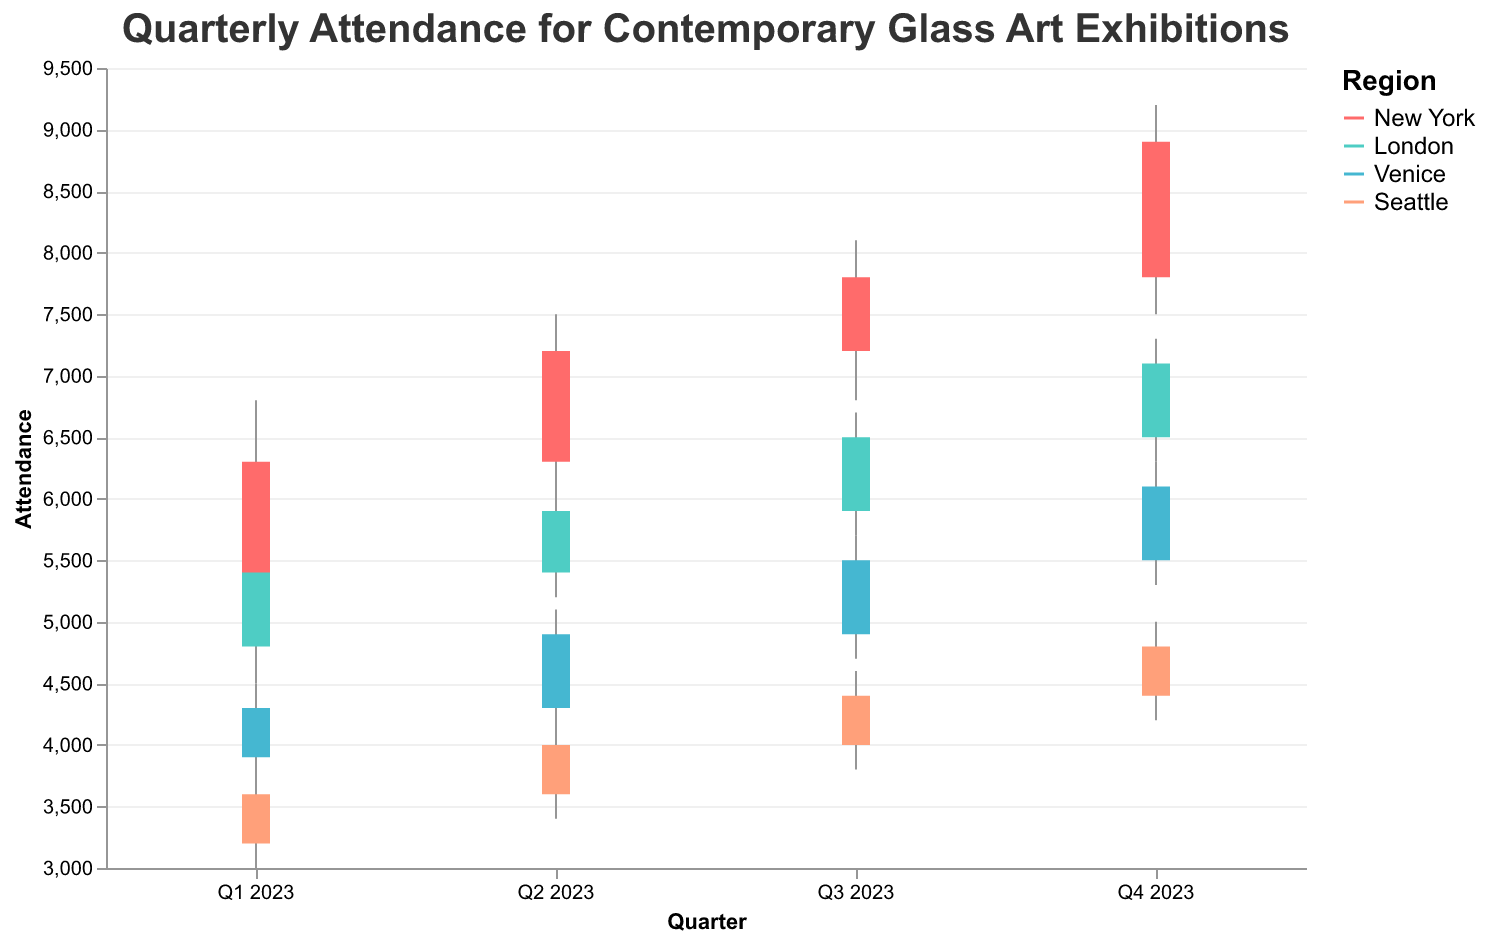What is the highest attendance recorded in New York in 2023? The highest attendance in New York is represented by the "High" value in each quarter. The highest "High" value is 9200 in Q4 2023.
Answer: 9200 How did the attendance in London change from Q1 2023 to Q2 2023? To determine how attendance changed, compare the "Close" value from Q1 2023 (5400) with the "Open" value from Q2 2023 (5400). The attendance opened and closed at the same value, indicating no initial change between the quarters. However, during Q2 2023, there were fluctuations.
Answer: No initial change, but fluctuations occurred What is the range of attendance in Venice during Q3 2023? The range is calculated by subtracting the "Low" value from the "High" value for Q3 2023 in Venice. The calculation is 5700 - 4700.
Answer: 1000 Compare the closing attendance in Seattle for Q2 2023 and Q4 2023. Which quarter saw more attendees? To compare the closing attendance, look at the "Close" values in Q2 2023 (4000) and Q4 2023 (4800). The comparison shows that Q4 2023 had more attendees.
Answer: Q4 2023 What's the average closing attendance across all regions for each quarter? (Consider one example quarter) Let's find the average for Q1 2023. The "Close" values are 6300 (New York), 5400 (London), 4300 (Venice), and 3600 (Seattle). The sum is 6300 + 5400 + 4300 + 3600 = 19600. By dividing by 4, the average closing attendance for Q1 2023 is 19600/4.
Answer: 4900 In which quarter did New York see the smallest variation in attendance? Variation refers to the difference between the "High" and "Low" values. Compare the ranges in each quarter for New York: Q1 (6800-4900=1900), Q2 (7500-6100=1400), Q3 (8100-6800=1300), Q4 (9200-7500=1700). The smallest variation occurred in Q3 2023.
Answer: Q3 2023 Which region had the highest opening attendance in Q4 2023? Examine the "Open" values for Q4 2023 for all regions: New York (7800), London (6500), Venice (5500), Seattle (4400). The highest "Open" value is 7800 in New York.
Answer: New York What is the average attendance for London across all quarters in 2023? First, sum the "Close" values for London across all quarters: 5400 (Q1) + 5900 (Q2) + 6500 (Q3) + 7100 (Q4). The total sum is 5400 + 5900 + 6500 + 7100 = 24900. Divide by 4 to get the average.
Answer: 6225 